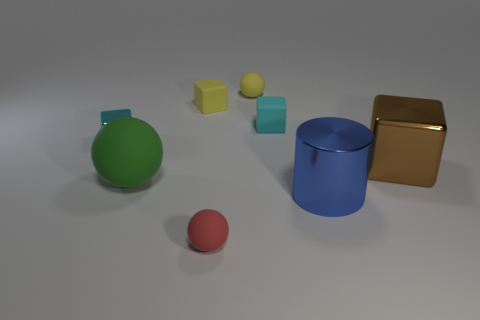Do the cyan thing on the left side of the cyan rubber object and the metal thing that is in front of the brown block have the same size?
Give a very brief answer. No. There is a cyan cube that is left of the tiny cyan matte cube; what size is it?
Offer a very short reply. Small. Is the number of small yellow matte spheres that are in front of the large blue cylinder less than the number of small cyan rubber cubes that are in front of the cyan rubber cube?
Keep it short and to the point. No. There is a thing that is left of the yellow cube and in front of the big brown metal cube; what material is it made of?
Ensure brevity in your answer.  Rubber. What shape is the large object left of the sphere behind the big green matte thing?
Ensure brevity in your answer.  Sphere. Does the cylinder have the same color as the big matte ball?
Your answer should be very brief. No. What size is the red object that is the same shape as the large green object?
Make the answer very short. Small. There is a shiny cube that is on the left side of the large brown shiny object; what number of small cyan blocks are behind it?
Ensure brevity in your answer.  1. Does the small object in front of the large blue cylinder have the same material as the large ball on the right side of the small shiny block?
Offer a terse response. Yes. How many other cyan objects have the same shape as the small metallic thing?
Your response must be concise. 1. 